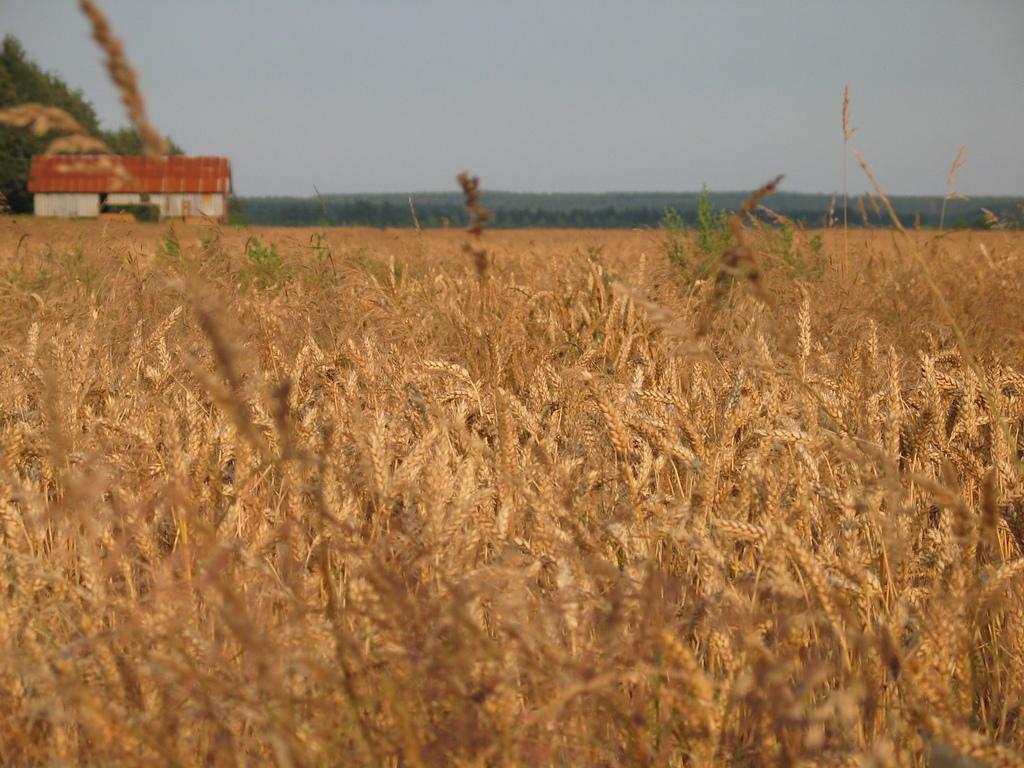What type of plant can be seen in the image? There is a food crop in the image. What structure is located on the left side of the image? There is a house on the left side of the image. What can be seen in the background of the image? There are trees and the sky visible in the background of the image. Can you tell me who the secretary is in the image? There is: There is no secretary present in the image. What type of hydrant is visible in the image? There is no hydrant present in the image. 